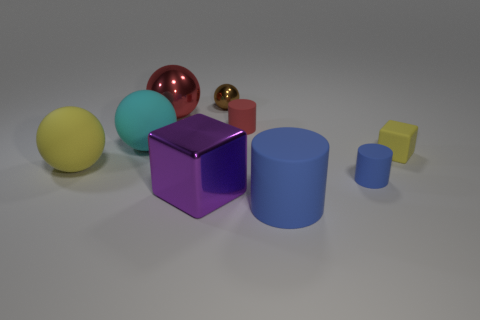Is there a small rubber cylinder of the same color as the tiny rubber block?
Offer a terse response. No. Is the big cylinder made of the same material as the block that is on the left side of the brown object?
Give a very brief answer. No. How many big things are either red metal objects or brown things?
Your response must be concise. 1. There is a small thing that is the same color as the large cylinder; what material is it?
Keep it short and to the point. Rubber. Are there fewer tiny red things than blocks?
Provide a succinct answer. Yes. There is a metallic ball that is to the left of the purple cube; does it have the same size as the matte ball that is on the right side of the yellow ball?
Make the answer very short. Yes. How many brown objects are big metal blocks or metallic cylinders?
Keep it short and to the point. 0. What is the size of the object that is the same color as the matte cube?
Offer a terse response. Large. Is the number of big metallic cubes greater than the number of tiny rubber things?
Provide a short and direct response. No. Is the color of the matte cube the same as the metal block?
Your answer should be very brief. No. 